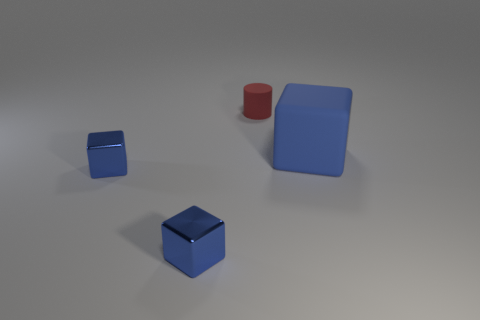How big is the cube to the right of the thing behind the thing that is on the right side of the small red rubber cylinder?
Keep it short and to the point. Large. How many other objects are there of the same material as the tiny cylinder?
Provide a succinct answer. 1. There is a matte thing that is in front of the matte cylinder; what size is it?
Your answer should be very brief. Large. How many things are both behind the large blue matte object and in front of the small red cylinder?
Keep it short and to the point. 0. There is a block to the right of the tiny object behind the large block; what is its material?
Your answer should be very brief. Rubber. Is there a blue metallic block?
Make the answer very short. Yes. What shape is the red thing that is made of the same material as the big cube?
Provide a succinct answer. Cylinder. What is the object behind the large blue object made of?
Offer a very short reply. Rubber. Is the color of the matte object that is behind the big matte object the same as the rubber block?
Your answer should be very brief. No. What size is the blue block that is on the right side of the matte thing behind the big blue matte thing?
Keep it short and to the point. Large. 